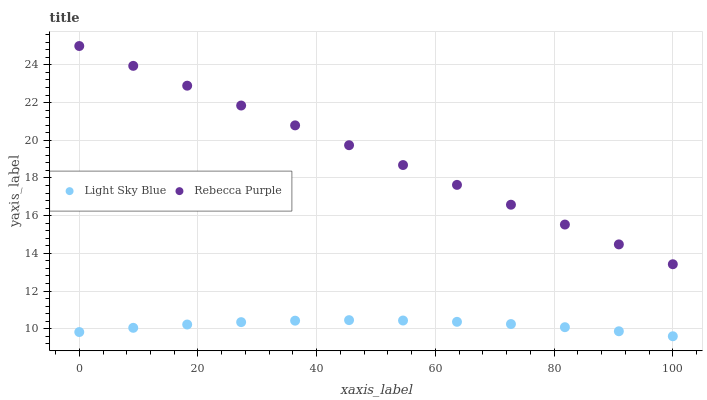Does Light Sky Blue have the minimum area under the curve?
Answer yes or no. Yes. Does Rebecca Purple have the maximum area under the curve?
Answer yes or no. Yes. Does Rebecca Purple have the minimum area under the curve?
Answer yes or no. No. Is Rebecca Purple the smoothest?
Answer yes or no. Yes. Is Light Sky Blue the roughest?
Answer yes or no. Yes. Is Rebecca Purple the roughest?
Answer yes or no. No. Does Light Sky Blue have the lowest value?
Answer yes or no. Yes. Does Rebecca Purple have the lowest value?
Answer yes or no. No. Does Rebecca Purple have the highest value?
Answer yes or no. Yes. Is Light Sky Blue less than Rebecca Purple?
Answer yes or no. Yes. Is Rebecca Purple greater than Light Sky Blue?
Answer yes or no. Yes. Does Light Sky Blue intersect Rebecca Purple?
Answer yes or no. No. 